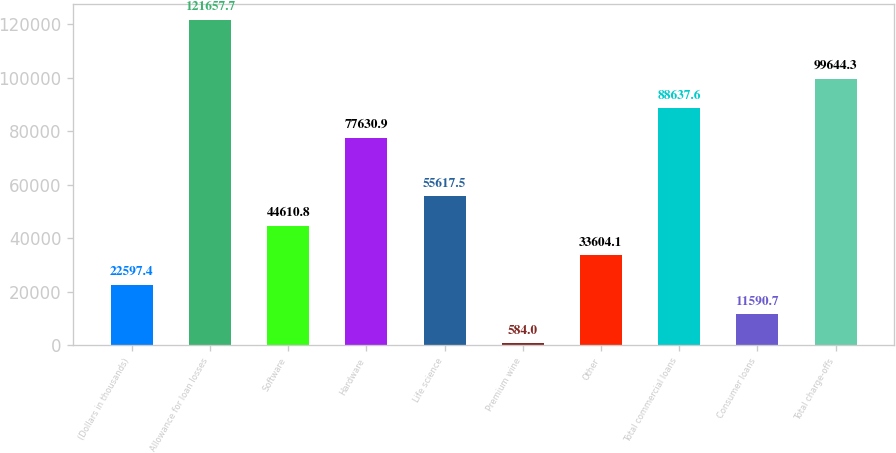Convert chart. <chart><loc_0><loc_0><loc_500><loc_500><bar_chart><fcel>(Dollars in thousands)<fcel>Allowance for loan losses<fcel>Software<fcel>Hardware<fcel>Life science<fcel>Premium wine<fcel>Other<fcel>Total commercial loans<fcel>Consumer loans<fcel>Total charge-offs<nl><fcel>22597.4<fcel>121658<fcel>44610.8<fcel>77630.9<fcel>55617.5<fcel>584<fcel>33604.1<fcel>88637.6<fcel>11590.7<fcel>99644.3<nl></chart> 